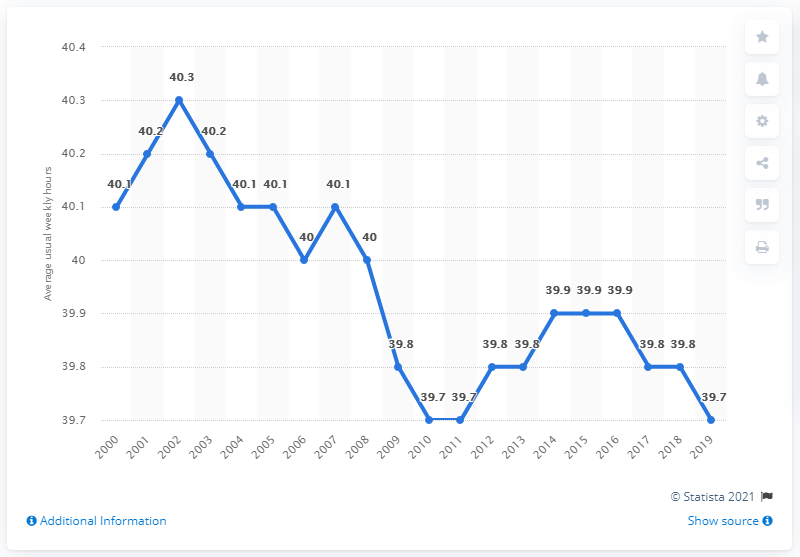Specify some key components in this picture. The largest value minus the smallest value is 0.6, which is the result of the range of values from 0.6 to 0. The average data point from 2014 to 2016 was 39.9. 